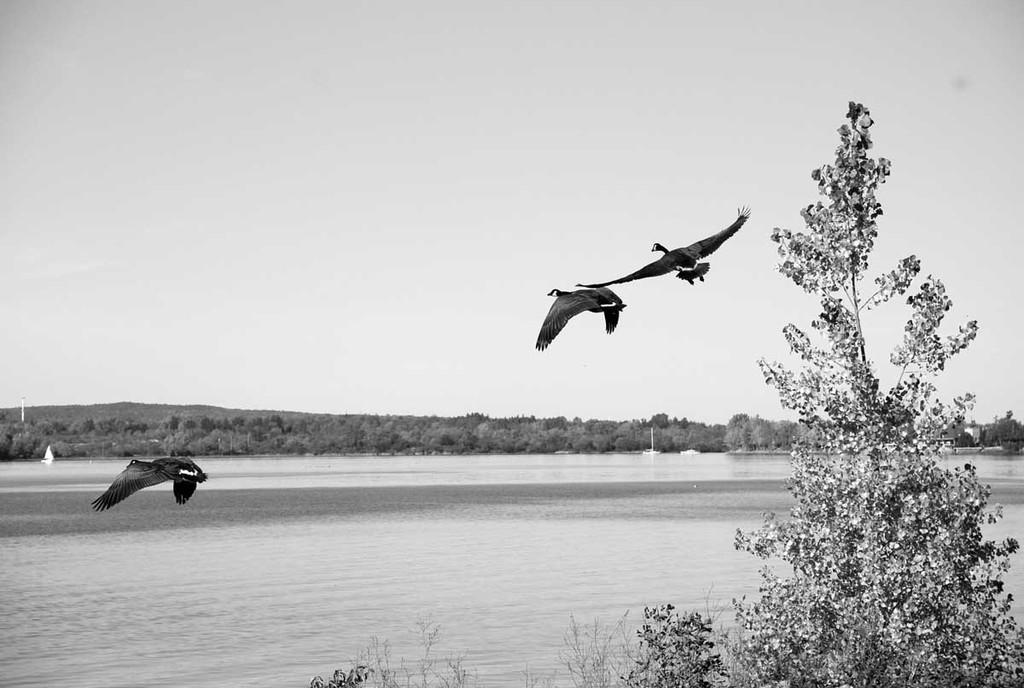In one or two sentences, can you explain what this image depicts? In this image I can see at the bottom there is water. In the middle three birds are flying. At the back side there are trees, at the top it is the sky. 